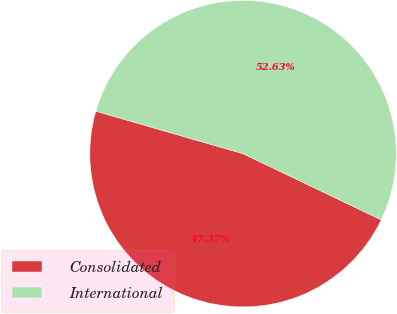Convert chart. <chart><loc_0><loc_0><loc_500><loc_500><pie_chart><fcel>Consolidated<fcel>International<nl><fcel>47.37%<fcel>52.63%<nl></chart> 